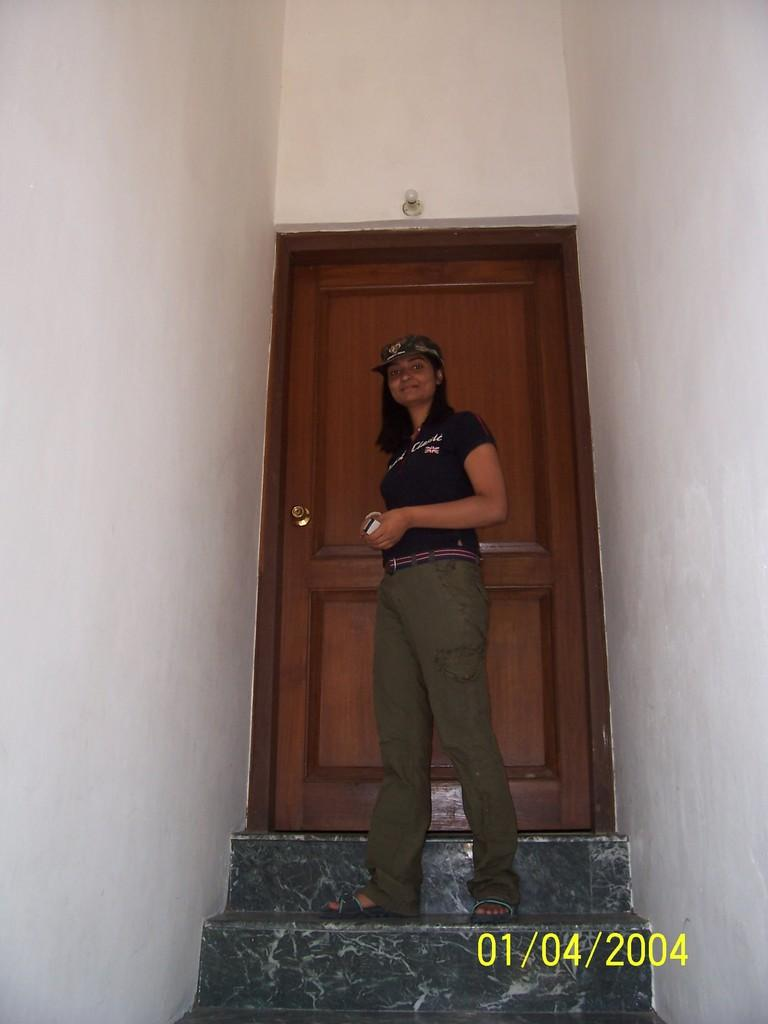Where was the image taken? The image is taken indoors. What is the woman in the image doing? The woman is standing on the stairs in the middle of the image. What can be seen in the background of the image? There are walls and a door in the background of the image. What type of breakfast is being served on the stairs in the image? There is no breakfast visible in the image; it only shows a woman standing on the stairs. 